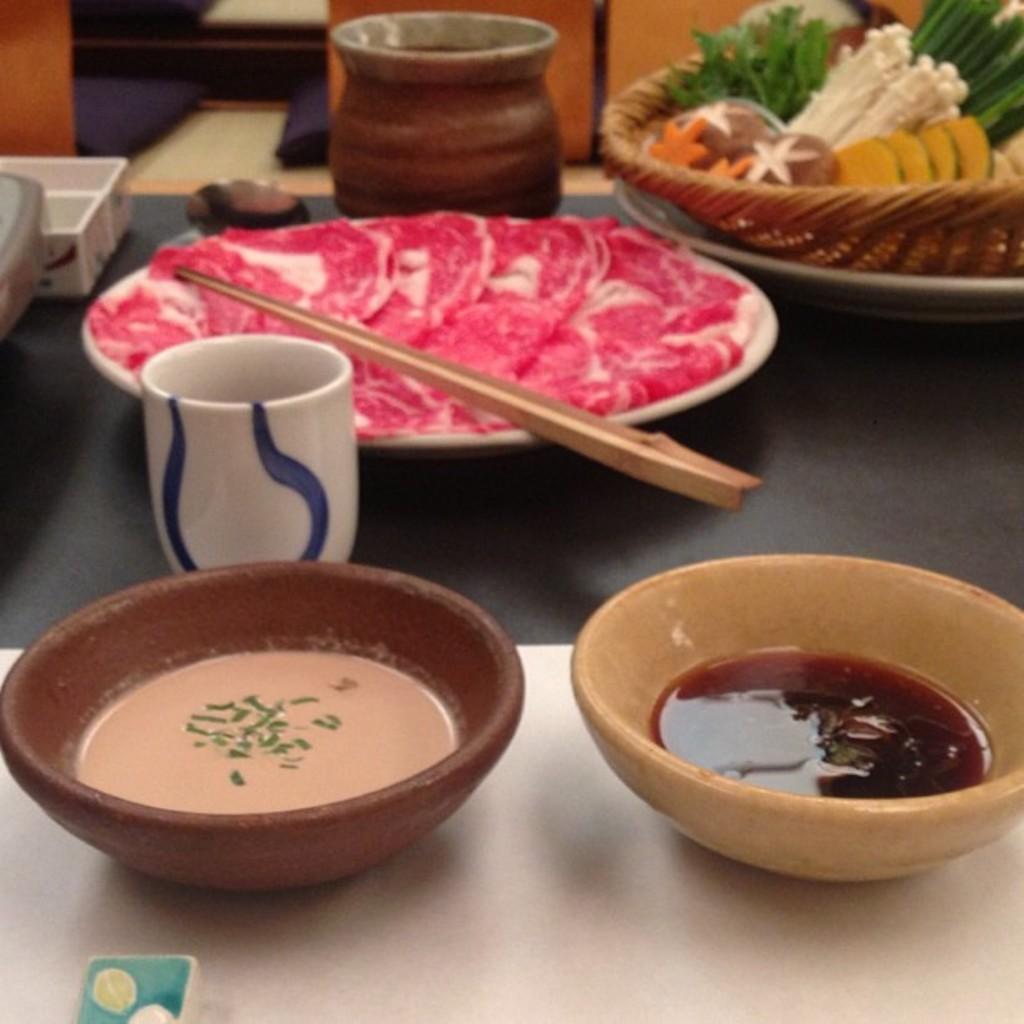Please provide a concise description of this image. In the image we can see there are bowls in which there are soups and curry and in a plate there is chopsticks and in a basket there are food items and a glass on the table. 